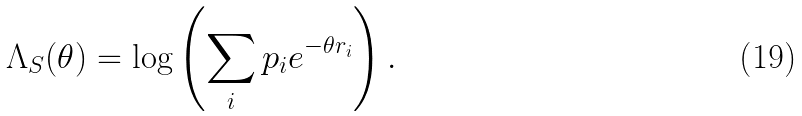Convert formula to latex. <formula><loc_0><loc_0><loc_500><loc_500>\Lambda _ { S } ( \theta ) = \log \left ( \sum _ { i } p _ { i } e ^ { - \theta r _ { i } } \right ) .</formula> 